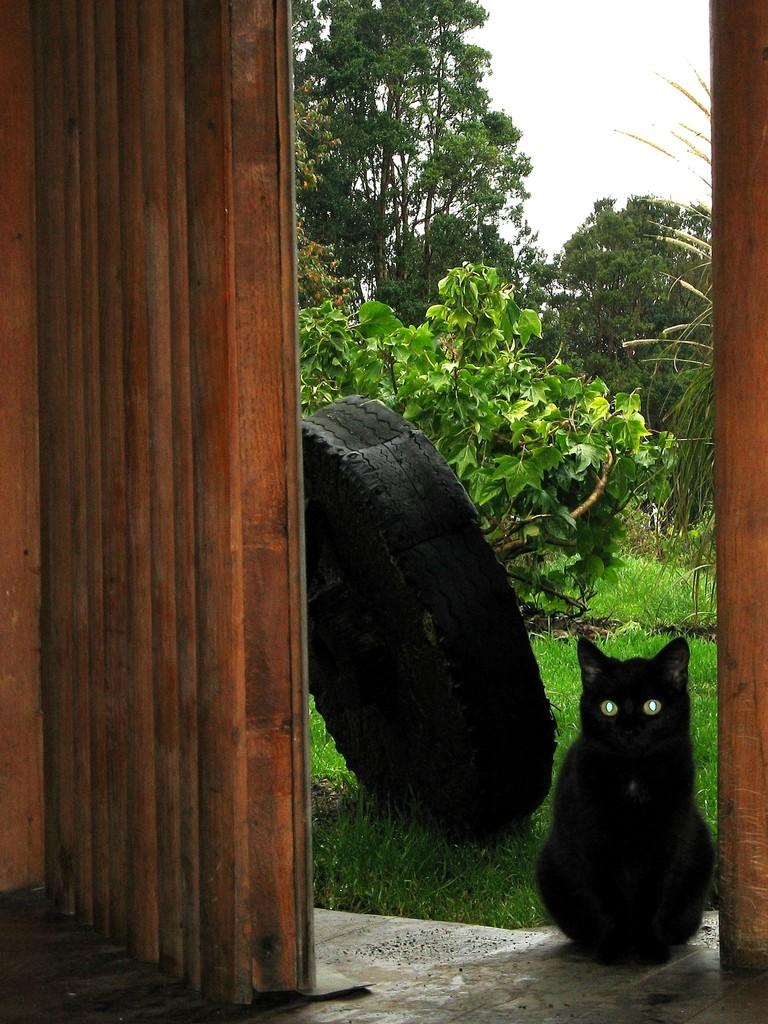What color is the car in the image? The car in the image is black. What part of the car can be seen in the image? There is a tire visible in the image. What type of natural environment is present in the image? There is grass, plants, and trees in the image. What is visible in the background of the image? The sky is visible in the image. What type of shirt is the ant wearing in the image? There is no ant present in the image, and therefore no shirt or any clothing item can be observed. 